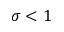<formula> <loc_0><loc_0><loc_500><loc_500>\sigma < 1</formula> 